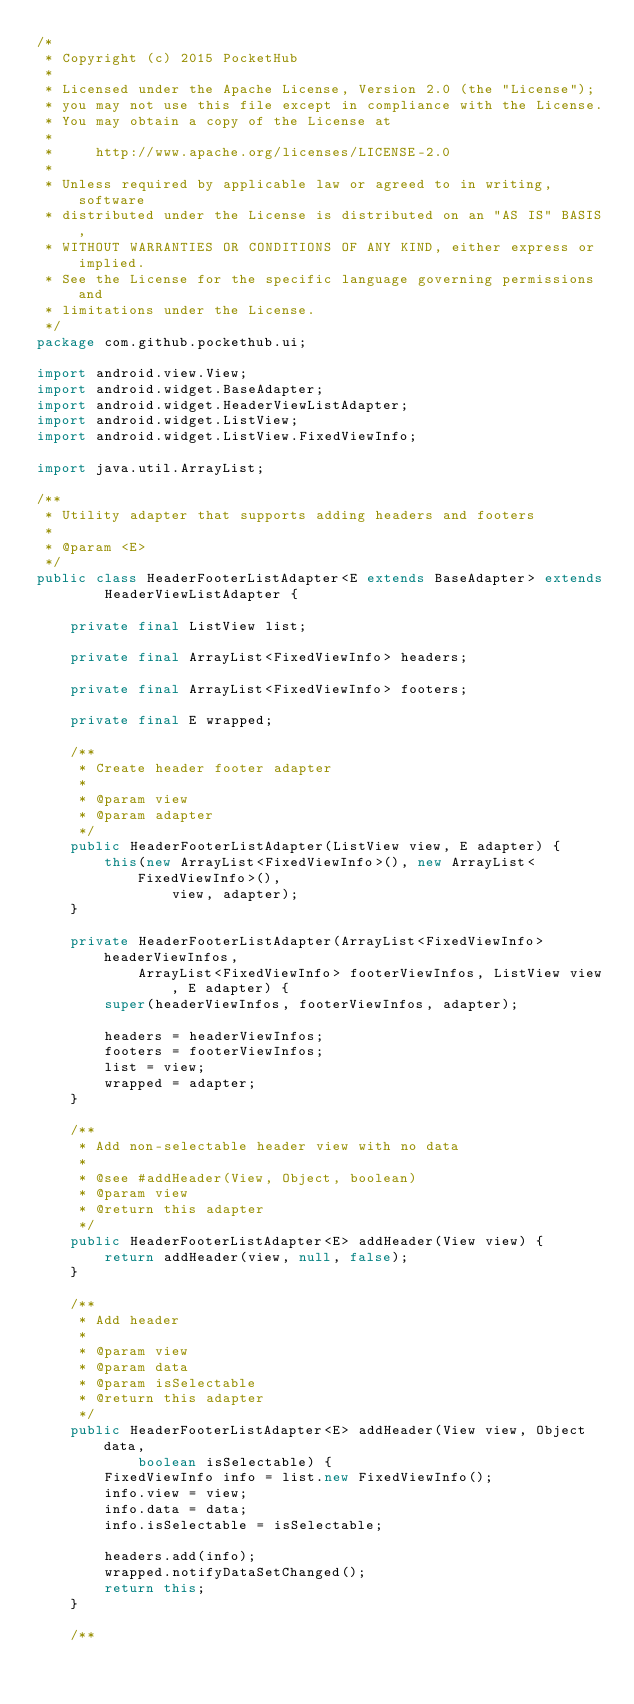<code> <loc_0><loc_0><loc_500><loc_500><_Java_>/*
 * Copyright (c) 2015 PocketHub
 *
 * Licensed under the Apache License, Version 2.0 (the "License");
 * you may not use this file except in compliance with the License.
 * You may obtain a copy of the License at
 *
 *     http://www.apache.org/licenses/LICENSE-2.0
 *
 * Unless required by applicable law or agreed to in writing, software
 * distributed under the License is distributed on an "AS IS" BASIS,
 * WITHOUT WARRANTIES OR CONDITIONS OF ANY KIND, either express or implied.
 * See the License for the specific language governing permissions and
 * limitations under the License.
 */
package com.github.pockethub.ui;

import android.view.View;
import android.widget.BaseAdapter;
import android.widget.HeaderViewListAdapter;
import android.widget.ListView;
import android.widget.ListView.FixedViewInfo;

import java.util.ArrayList;

/**
 * Utility adapter that supports adding headers and footers
 *
 * @param <E>
 */
public class HeaderFooterListAdapter<E extends BaseAdapter> extends
        HeaderViewListAdapter {

    private final ListView list;

    private final ArrayList<FixedViewInfo> headers;

    private final ArrayList<FixedViewInfo> footers;

    private final E wrapped;

    /**
     * Create header footer adapter
     *
     * @param view
     * @param adapter
     */
    public HeaderFooterListAdapter(ListView view, E adapter) {
        this(new ArrayList<FixedViewInfo>(), new ArrayList<FixedViewInfo>(),
                view, adapter);
    }

    private HeaderFooterListAdapter(ArrayList<FixedViewInfo> headerViewInfos,
            ArrayList<FixedViewInfo> footerViewInfos, ListView view, E adapter) {
        super(headerViewInfos, footerViewInfos, adapter);

        headers = headerViewInfos;
        footers = footerViewInfos;
        list = view;
        wrapped = adapter;
    }

    /**
     * Add non-selectable header view with no data
     *
     * @see #addHeader(View, Object, boolean)
     * @param view
     * @return this adapter
     */
    public HeaderFooterListAdapter<E> addHeader(View view) {
        return addHeader(view, null, false);
    }

    /**
     * Add header
     *
     * @param view
     * @param data
     * @param isSelectable
     * @return this adapter
     */
    public HeaderFooterListAdapter<E> addHeader(View view, Object data,
            boolean isSelectable) {
        FixedViewInfo info = list.new FixedViewInfo();
        info.view = view;
        info.data = data;
        info.isSelectable = isSelectable;

        headers.add(info);
        wrapped.notifyDataSetChanged();
        return this;
    }

    /**</code> 